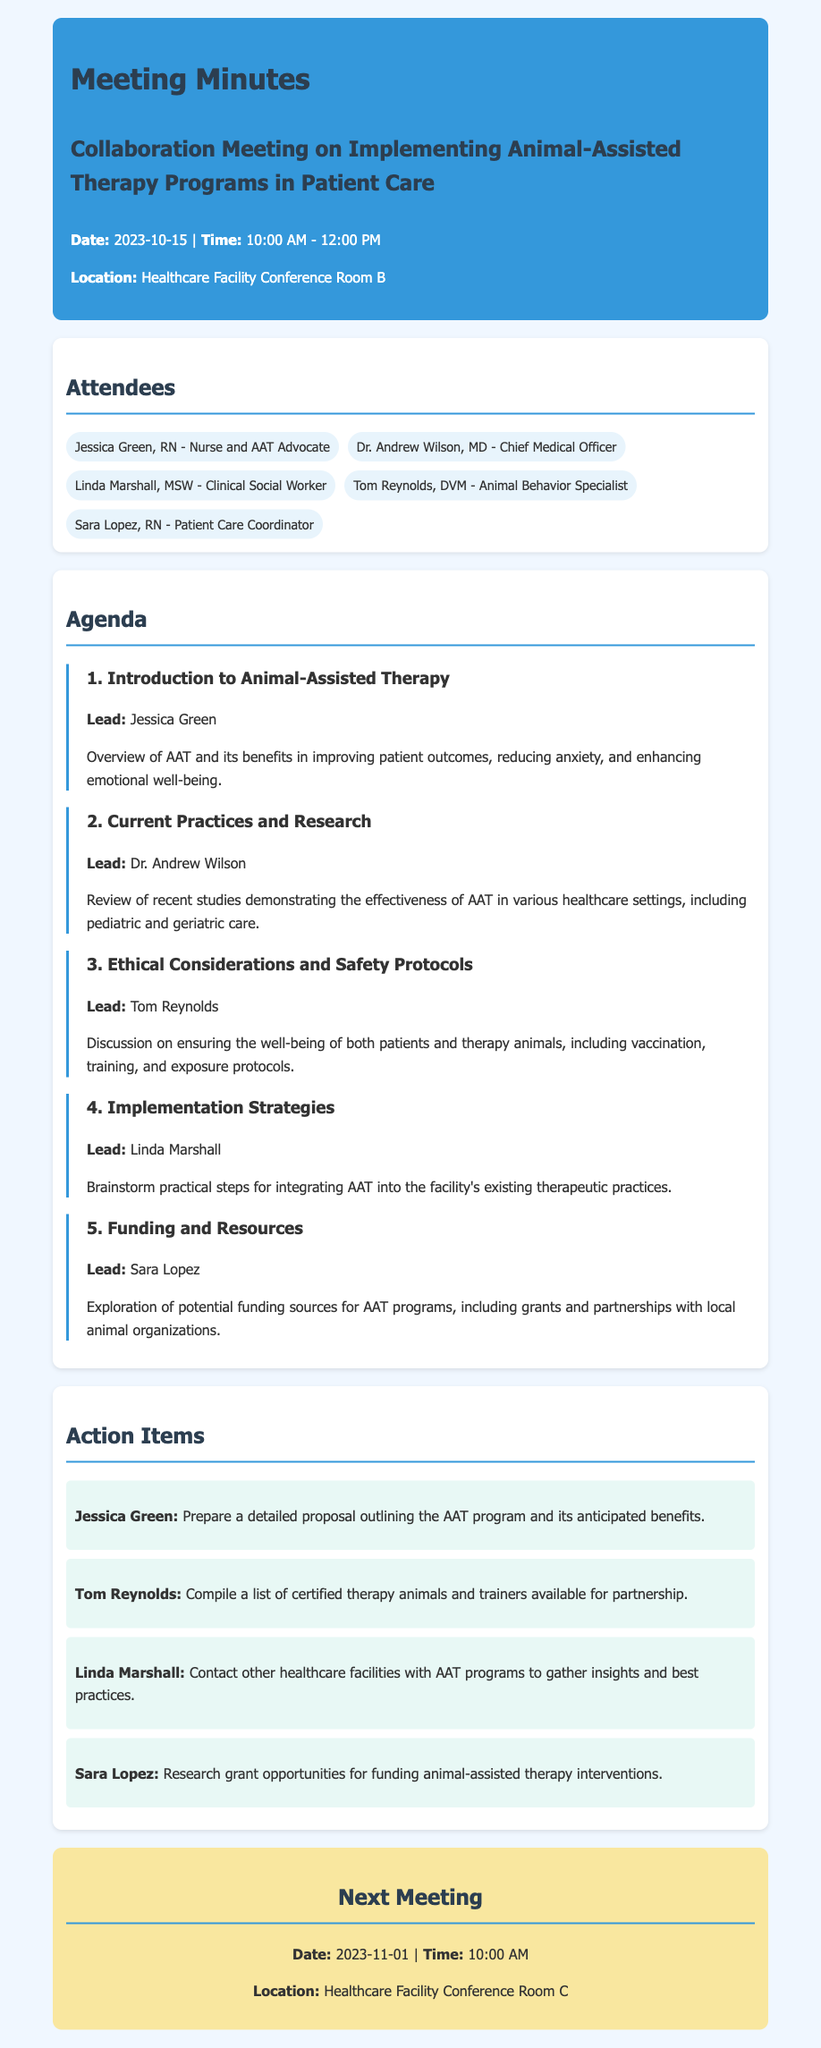What is the date of the meeting? The date of the meeting is clearly mentioned at the beginning of the document.
Answer: 2023-10-15 Who leads the introduction to Animal-Assisted Therapy? The document identifies Jessica Green as the lead for this agenda item.
Answer: Jessica Green What are the two considerations discussed regarding therapy animals? The section on ethical considerations provides insights on patient and animal welfare, such as vaccination and training.
Answer: Welfare and training Which attendee is responsible for researching grant opportunities? The action items specify that Sara Lopez is tasked with this research.
Answer: Sara Lopez What is the time of the next meeting? The document outlines the scheduled start time for the next meeting.
Answer: 10:00 AM How many attendees participated in the meeting? The list of attendees includes five participants.
Answer: Five What topic did Linda Marshall lead during the meeting? The agenda indicates that Linda Marshall focused on implementation strategies.
Answer: Implementation strategies What funding sources were discussed for the AAT program? The exploration of potential funding sources includes grants and local partnerships.
Answer: Grants and partnerships 